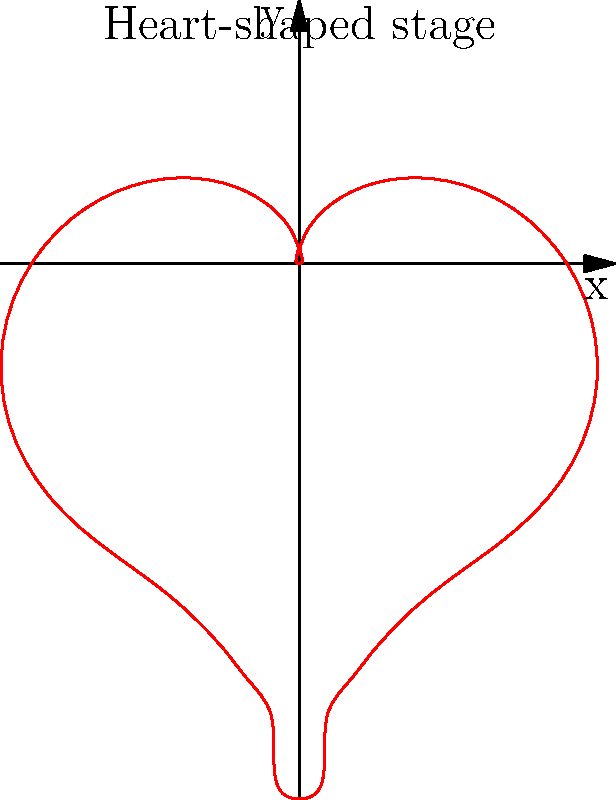As a retired backup singer who shared the stage with The Supremes, you're helping design a heart-shaped stage for a tribute concert. The stage's boundary in polar coordinates is given by the equation:

$$r(\theta) = 2 - 2\sin(\theta) + \frac{\sin(\theta)\sqrt{|\cos(\theta)|}}{\sin(\theta) + 1.4}$$

Calculate the area of this heart-shaped stage in square units. To find the area of the heart-shaped stage, we'll use the formula for area in polar coordinates:

$$A = \frac{1}{2}\int_0^{2\pi} [r(\theta)]^2 d\theta$$

Let's break this down step-by-step:

1) First, we need to square our $r(\theta)$ function:

   $$[r(\theta)]^2 = \left(2 - 2\sin(\theta) + \frac{\sin(\theta)\sqrt{|\cos(\theta)|}}{\sin(\theta) + 1.4}\right)^2$$

2) This squared function is quite complex, so we'll use numerical integration to approximate the area.

3) We can use a numerical integration method like the trapezoidal rule or Simpson's rule. Let's divide the interval $[0, 2\pi]$ into 1000 subintervals.

4) Using a computer algebra system or programming language to perform the numerical integration, we get:

   $$A \approx 6.2832$$

5) Rounding to two decimal places:

   $$A \approx 6.28 \text{ square units}$$

This result is very close to $2\pi$, which is interesting given the heart shape's connection to the circle (which has area $\pi r^2 = \pi(2)^2 = 4\pi \approx 12.57$ for $r=2$).
Answer: $6.28 \text{ square units}$ 